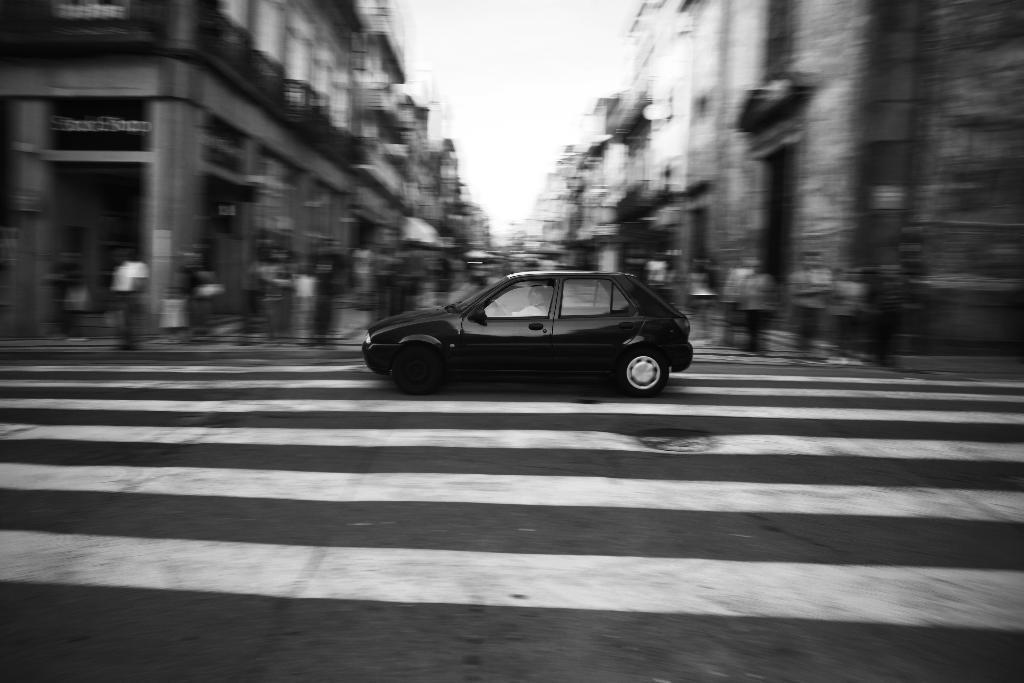Can you describe this image briefly? In the middle I can see a car and a crowd on the road. In the background I can see buildings and the sky. This image is taken may be on the road. 